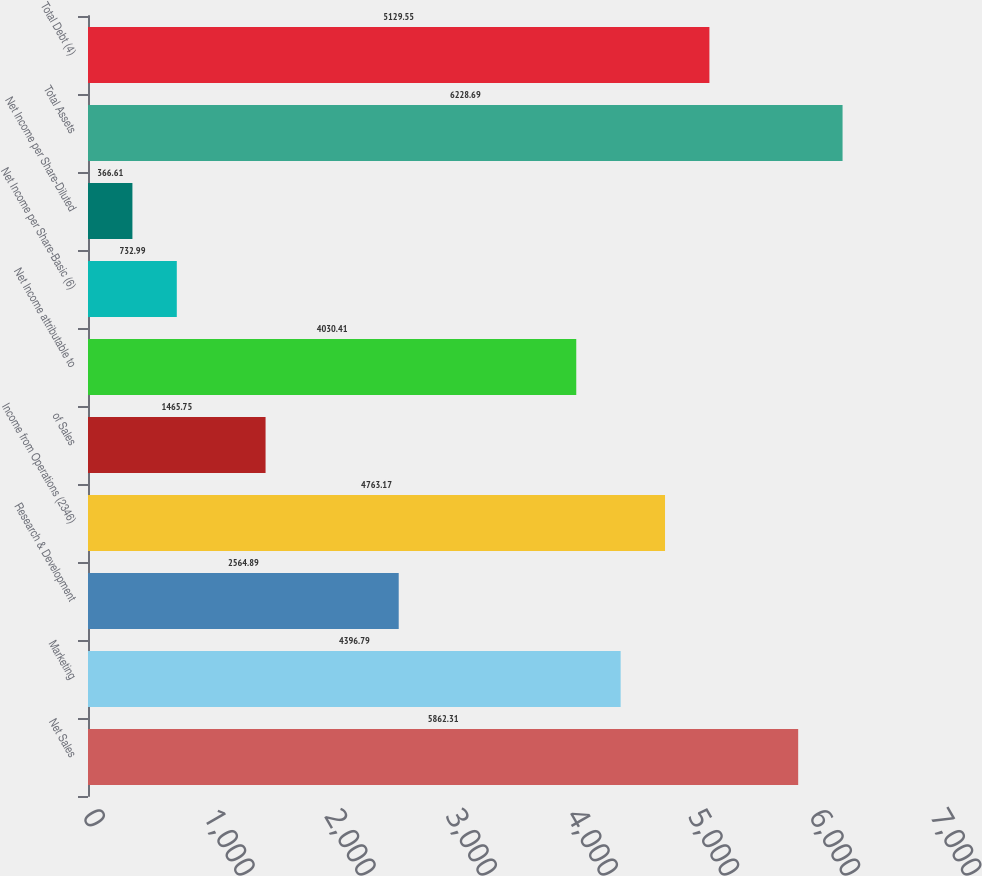<chart> <loc_0><loc_0><loc_500><loc_500><bar_chart><fcel>Net Sales<fcel>Marketing<fcel>Research & Development<fcel>Income from Operations (2346)<fcel>of Sales<fcel>Net Income attributable to<fcel>Net Income per Share-Basic (6)<fcel>Net Income per Share-Diluted<fcel>Total Assets<fcel>Total Debt (4)<nl><fcel>5862.31<fcel>4396.79<fcel>2564.89<fcel>4763.17<fcel>1465.75<fcel>4030.41<fcel>732.99<fcel>366.61<fcel>6228.69<fcel>5129.55<nl></chart> 